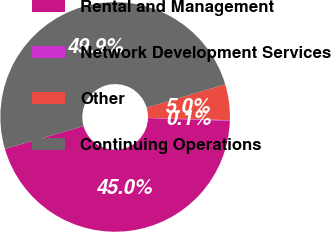Convert chart to OTSL. <chart><loc_0><loc_0><loc_500><loc_500><pie_chart><fcel>Rental and Management<fcel>Network Development Services<fcel>Other<fcel>Continuing Operations<nl><fcel>44.97%<fcel>0.09%<fcel>5.03%<fcel>49.91%<nl></chart> 